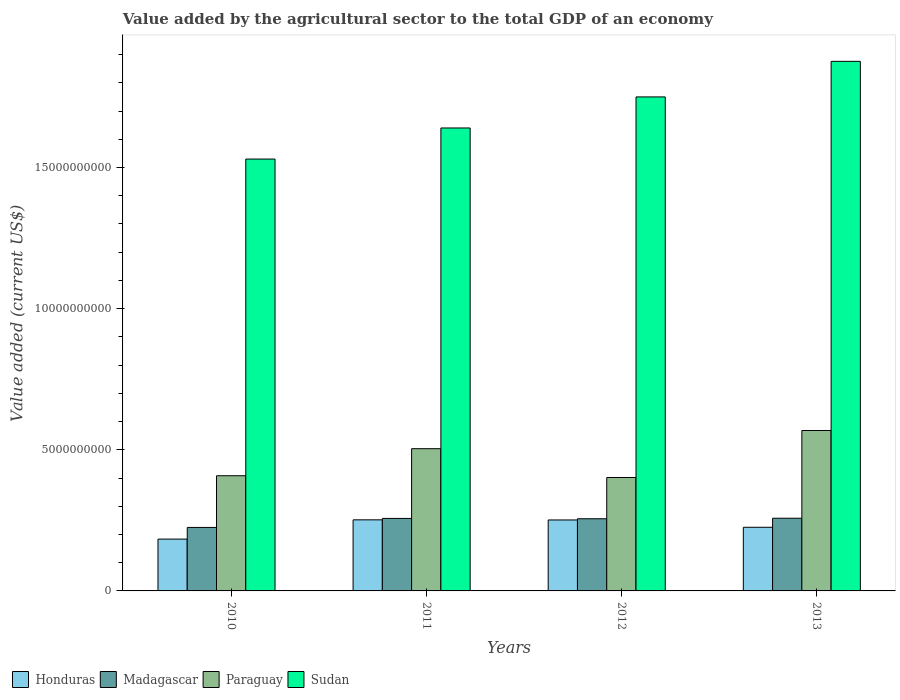How many different coloured bars are there?
Offer a very short reply. 4. How many bars are there on the 2nd tick from the left?
Your answer should be compact. 4. How many bars are there on the 4th tick from the right?
Give a very brief answer. 4. What is the label of the 2nd group of bars from the left?
Your response must be concise. 2011. What is the value added by the agricultural sector to the total GDP in Honduras in 2010?
Your answer should be compact. 1.84e+09. Across all years, what is the maximum value added by the agricultural sector to the total GDP in Honduras?
Give a very brief answer. 2.52e+09. Across all years, what is the minimum value added by the agricultural sector to the total GDP in Madagascar?
Provide a short and direct response. 2.25e+09. In which year was the value added by the agricultural sector to the total GDP in Madagascar maximum?
Keep it short and to the point. 2013. In which year was the value added by the agricultural sector to the total GDP in Madagascar minimum?
Your response must be concise. 2010. What is the total value added by the agricultural sector to the total GDP in Madagascar in the graph?
Offer a very short reply. 9.95e+09. What is the difference between the value added by the agricultural sector to the total GDP in Honduras in 2012 and that in 2013?
Keep it short and to the point. 2.59e+08. What is the difference between the value added by the agricultural sector to the total GDP in Sudan in 2011 and the value added by the agricultural sector to the total GDP in Honduras in 2012?
Give a very brief answer. 1.39e+1. What is the average value added by the agricultural sector to the total GDP in Sudan per year?
Your answer should be very brief. 1.70e+1. In the year 2011, what is the difference between the value added by the agricultural sector to the total GDP in Sudan and value added by the agricultural sector to the total GDP in Paraguay?
Provide a short and direct response. 1.14e+1. In how many years, is the value added by the agricultural sector to the total GDP in Honduras greater than 14000000000 US$?
Provide a succinct answer. 0. What is the ratio of the value added by the agricultural sector to the total GDP in Paraguay in 2010 to that in 2013?
Your answer should be compact. 0.72. Is the value added by the agricultural sector to the total GDP in Sudan in 2011 less than that in 2012?
Ensure brevity in your answer.  Yes. Is the difference between the value added by the agricultural sector to the total GDP in Sudan in 2012 and 2013 greater than the difference between the value added by the agricultural sector to the total GDP in Paraguay in 2012 and 2013?
Give a very brief answer. Yes. What is the difference between the highest and the second highest value added by the agricultural sector to the total GDP in Honduras?
Your response must be concise. 4.70e+06. What is the difference between the highest and the lowest value added by the agricultural sector to the total GDP in Honduras?
Offer a terse response. 6.82e+08. In how many years, is the value added by the agricultural sector to the total GDP in Honduras greater than the average value added by the agricultural sector to the total GDP in Honduras taken over all years?
Give a very brief answer. 2. What does the 3rd bar from the left in 2012 represents?
Make the answer very short. Paraguay. What does the 1st bar from the right in 2010 represents?
Ensure brevity in your answer.  Sudan. Is it the case that in every year, the sum of the value added by the agricultural sector to the total GDP in Paraguay and value added by the agricultural sector to the total GDP in Madagascar is greater than the value added by the agricultural sector to the total GDP in Honduras?
Keep it short and to the point. Yes. How many bars are there?
Provide a short and direct response. 16. Are all the bars in the graph horizontal?
Keep it short and to the point. No. Are the values on the major ticks of Y-axis written in scientific E-notation?
Your answer should be compact. No. Does the graph contain any zero values?
Provide a short and direct response. No. Does the graph contain grids?
Offer a very short reply. No. How are the legend labels stacked?
Provide a succinct answer. Horizontal. What is the title of the graph?
Provide a succinct answer. Value added by the agricultural sector to the total GDP of an economy. Does "Guinea" appear as one of the legend labels in the graph?
Your answer should be compact. No. What is the label or title of the X-axis?
Make the answer very short. Years. What is the label or title of the Y-axis?
Provide a short and direct response. Value added (current US$). What is the Value added (current US$) of Honduras in 2010?
Make the answer very short. 1.84e+09. What is the Value added (current US$) of Madagascar in 2010?
Offer a terse response. 2.25e+09. What is the Value added (current US$) of Paraguay in 2010?
Offer a very short reply. 4.08e+09. What is the Value added (current US$) of Sudan in 2010?
Give a very brief answer. 1.53e+1. What is the Value added (current US$) of Honduras in 2011?
Your answer should be compact. 2.52e+09. What is the Value added (current US$) of Madagascar in 2011?
Your answer should be compact. 2.57e+09. What is the Value added (current US$) of Paraguay in 2011?
Provide a short and direct response. 5.04e+09. What is the Value added (current US$) of Sudan in 2011?
Your answer should be compact. 1.64e+1. What is the Value added (current US$) in Honduras in 2012?
Your answer should be very brief. 2.51e+09. What is the Value added (current US$) in Madagascar in 2012?
Your answer should be compact. 2.56e+09. What is the Value added (current US$) in Paraguay in 2012?
Offer a terse response. 4.02e+09. What is the Value added (current US$) in Sudan in 2012?
Your response must be concise. 1.75e+1. What is the Value added (current US$) of Honduras in 2013?
Keep it short and to the point. 2.25e+09. What is the Value added (current US$) of Madagascar in 2013?
Your answer should be compact. 2.58e+09. What is the Value added (current US$) of Paraguay in 2013?
Offer a very short reply. 5.68e+09. What is the Value added (current US$) of Sudan in 2013?
Give a very brief answer. 1.88e+1. Across all years, what is the maximum Value added (current US$) of Honduras?
Offer a very short reply. 2.52e+09. Across all years, what is the maximum Value added (current US$) in Madagascar?
Provide a succinct answer. 2.58e+09. Across all years, what is the maximum Value added (current US$) in Paraguay?
Provide a short and direct response. 5.68e+09. Across all years, what is the maximum Value added (current US$) in Sudan?
Make the answer very short. 1.88e+1. Across all years, what is the minimum Value added (current US$) in Honduras?
Your answer should be very brief. 1.84e+09. Across all years, what is the minimum Value added (current US$) of Madagascar?
Give a very brief answer. 2.25e+09. Across all years, what is the minimum Value added (current US$) of Paraguay?
Give a very brief answer. 4.02e+09. Across all years, what is the minimum Value added (current US$) in Sudan?
Give a very brief answer. 1.53e+1. What is the total Value added (current US$) in Honduras in the graph?
Your answer should be compact. 9.12e+09. What is the total Value added (current US$) in Madagascar in the graph?
Provide a short and direct response. 9.95e+09. What is the total Value added (current US$) in Paraguay in the graph?
Make the answer very short. 1.88e+1. What is the total Value added (current US$) of Sudan in the graph?
Provide a short and direct response. 6.80e+1. What is the difference between the Value added (current US$) of Honduras in 2010 and that in 2011?
Give a very brief answer. -6.82e+08. What is the difference between the Value added (current US$) of Madagascar in 2010 and that in 2011?
Ensure brevity in your answer.  -3.19e+08. What is the difference between the Value added (current US$) of Paraguay in 2010 and that in 2011?
Provide a succinct answer. -9.58e+08. What is the difference between the Value added (current US$) in Sudan in 2010 and that in 2011?
Provide a short and direct response. -1.10e+09. What is the difference between the Value added (current US$) in Honduras in 2010 and that in 2012?
Ensure brevity in your answer.  -6.78e+08. What is the difference between the Value added (current US$) in Madagascar in 2010 and that in 2012?
Ensure brevity in your answer.  -3.07e+08. What is the difference between the Value added (current US$) in Paraguay in 2010 and that in 2012?
Provide a short and direct response. 6.20e+07. What is the difference between the Value added (current US$) in Sudan in 2010 and that in 2012?
Your answer should be compact. -2.20e+09. What is the difference between the Value added (current US$) of Honduras in 2010 and that in 2013?
Your response must be concise. -4.19e+08. What is the difference between the Value added (current US$) in Madagascar in 2010 and that in 2013?
Make the answer very short. -3.26e+08. What is the difference between the Value added (current US$) in Paraguay in 2010 and that in 2013?
Your answer should be very brief. -1.60e+09. What is the difference between the Value added (current US$) of Sudan in 2010 and that in 2013?
Give a very brief answer. -3.46e+09. What is the difference between the Value added (current US$) in Honduras in 2011 and that in 2012?
Your answer should be compact. 4.70e+06. What is the difference between the Value added (current US$) of Madagascar in 2011 and that in 2012?
Provide a succinct answer. 1.16e+07. What is the difference between the Value added (current US$) of Paraguay in 2011 and that in 2012?
Keep it short and to the point. 1.02e+09. What is the difference between the Value added (current US$) in Sudan in 2011 and that in 2012?
Give a very brief answer. -1.10e+09. What is the difference between the Value added (current US$) in Honduras in 2011 and that in 2013?
Your answer should be very brief. 2.63e+08. What is the difference between the Value added (current US$) in Madagascar in 2011 and that in 2013?
Provide a short and direct response. -7.38e+06. What is the difference between the Value added (current US$) of Paraguay in 2011 and that in 2013?
Provide a succinct answer. -6.44e+08. What is the difference between the Value added (current US$) of Sudan in 2011 and that in 2013?
Provide a short and direct response. -2.36e+09. What is the difference between the Value added (current US$) in Honduras in 2012 and that in 2013?
Offer a terse response. 2.59e+08. What is the difference between the Value added (current US$) of Madagascar in 2012 and that in 2013?
Your answer should be very brief. -1.90e+07. What is the difference between the Value added (current US$) of Paraguay in 2012 and that in 2013?
Ensure brevity in your answer.  -1.66e+09. What is the difference between the Value added (current US$) of Sudan in 2012 and that in 2013?
Your response must be concise. -1.26e+09. What is the difference between the Value added (current US$) in Honduras in 2010 and the Value added (current US$) in Madagascar in 2011?
Your answer should be compact. -7.32e+08. What is the difference between the Value added (current US$) in Honduras in 2010 and the Value added (current US$) in Paraguay in 2011?
Your response must be concise. -3.20e+09. What is the difference between the Value added (current US$) of Honduras in 2010 and the Value added (current US$) of Sudan in 2011?
Give a very brief answer. -1.46e+1. What is the difference between the Value added (current US$) of Madagascar in 2010 and the Value added (current US$) of Paraguay in 2011?
Offer a very short reply. -2.79e+09. What is the difference between the Value added (current US$) in Madagascar in 2010 and the Value added (current US$) in Sudan in 2011?
Offer a terse response. -1.42e+1. What is the difference between the Value added (current US$) in Paraguay in 2010 and the Value added (current US$) in Sudan in 2011?
Your response must be concise. -1.23e+1. What is the difference between the Value added (current US$) in Honduras in 2010 and the Value added (current US$) in Madagascar in 2012?
Your response must be concise. -7.21e+08. What is the difference between the Value added (current US$) of Honduras in 2010 and the Value added (current US$) of Paraguay in 2012?
Provide a short and direct response. -2.18e+09. What is the difference between the Value added (current US$) in Honduras in 2010 and the Value added (current US$) in Sudan in 2012?
Your answer should be very brief. -1.57e+1. What is the difference between the Value added (current US$) in Madagascar in 2010 and the Value added (current US$) in Paraguay in 2012?
Ensure brevity in your answer.  -1.77e+09. What is the difference between the Value added (current US$) of Madagascar in 2010 and the Value added (current US$) of Sudan in 2012?
Your answer should be compact. -1.53e+1. What is the difference between the Value added (current US$) of Paraguay in 2010 and the Value added (current US$) of Sudan in 2012?
Offer a terse response. -1.34e+1. What is the difference between the Value added (current US$) in Honduras in 2010 and the Value added (current US$) in Madagascar in 2013?
Your answer should be compact. -7.40e+08. What is the difference between the Value added (current US$) of Honduras in 2010 and the Value added (current US$) of Paraguay in 2013?
Offer a terse response. -3.85e+09. What is the difference between the Value added (current US$) in Honduras in 2010 and the Value added (current US$) in Sudan in 2013?
Offer a very short reply. -1.69e+1. What is the difference between the Value added (current US$) in Madagascar in 2010 and the Value added (current US$) in Paraguay in 2013?
Ensure brevity in your answer.  -3.43e+09. What is the difference between the Value added (current US$) in Madagascar in 2010 and the Value added (current US$) in Sudan in 2013?
Your response must be concise. -1.65e+1. What is the difference between the Value added (current US$) in Paraguay in 2010 and the Value added (current US$) in Sudan in 2013?
Ensure brevity in your answer.  -1.47e+1. What is the difference between the Value added (current US$) in Honduras in 2011 and the Value added (current US$) in Madagascar in 2012?
Provide a succinct answer. -3.82e+07. What is the difference between the Value added (current US$) of Honduras in 2011 and the Value added (current US$) of Paraguay in 2012?
Give a very brief answer. -1.50e+09. What is the difference between the Value added (current US$) of Honduras in 2011 and the Value added (current US$) of Sudan in 2012?
Provide a succinct answer. -1.50e+1. What is the difference between the Value added (current US$) of Madagascar in 2011 and the Value added (current US$) of Paraguay in 2012?
Give a very brief answer. -1.45e+09. What is the difference between the Value added (current US$) of Madagascar in 2011 and the Value added (current US$) of Sudan in 2012?
Your response must be concise. -1.49e+1. What is the difference between the Value added (current US$) in Paraguay in 2011 and the Value added (current US$) in Sudan in 2012?
Make the answer very short. -1.25e+1. What is the difference between the Value added (current US$) in Honduras in 2011 and the Value added (current US$) in Madagascar in 2013?
Offer a very short reply. -5.72e+07. What is the difference between the Value added (current US$) of Honduras in 2011 and the Value added (current US$) of Paraguay in 2013?
Provide a short and direct response. -3.16e+09. What is the difference between the Value added (current US$) of Honduras in 2011 and the Value added (current US$) of Sudan in 2013?
Your response must be concise. -1.62e+1. What is the difference between the Value added (current US$) in Madagascar in 2011 and the Value added (current US$) in Paraguay in 2013?
Provide a short and direct response. -3.12e+09. What is the difference between the Value added (current US$) of Madagascar in 2011 and the Value added (current US$) of Sudan in 2013?
Give a very brief answer. -1.62e+1. What is the difference between the Value added (current US$) of Paraguay in 2011 and the Value added (current US$) of Sudan in 2013?
Give a very brief answer. -1.37e+1. What is the difference between the Value added (current US$) in Honduras in 2012 and the Value added (current US$) in Madagascar in 2013?
Ensure brevity in your answer.  -6.19e+07. What is the difference between the Value added (current US$) of Honduras in 2012 and the Value added (current US$) of Paraguay in 2013?
Provide a short and direct response. -3.17e+09. What is the difference between the Value added (current US$) in Honduras in 2012 and the Value added (current US$) in Sudan in 2013?
Your response must be concise. -1.62e+1. What is the difference between the Value added (current US$) in Madagascar in 2012 and the Value added (current US$) in Paraguay in 2013?
Keep it short and to the point. -3.13e+09. What is the difference between the Value added (current US$) of Madagascar in 2012 and the Value added (current US$) of Sudan in 2013?
Your answer should be very brief. -1.62e+1. What is the difference between the Value added (current US$) of Paraguay in 2012 and the Value added (current US$) of Sudan in 2013?
Provide a succinct answer. -1.47e+1. What is the average Value added (current US$) in Honduras per year?
Give a very brief answer. 2.28e+09. What is the average Value added (current US$) of Madagascar per year?
Provide a succinct answer. 2.49e+09. What is the average Value added (current US$) of Paraguay per year?
Provide a short and direct response. 4.71e+09. What is the average Value added (current US$) in Sudan per year?
Offer a terse response. 1.70e+1. In the year 2010, what is the difference between the Value added (current US$) of Honduras and Value added (current US$) of Madagascar?
Make the answer very short. -4.13e+08. In the year 2010, what is the difference between the Value added (current US$) of Honduras and Value added (current US$) of Paraguay?
Keep it short and to the point. -2.24e+09. In the year 2010, what is the difference between the Value added (current US$) in Honduras and Value added (current US$) in Sudan?
Offer a terse response. -1.35e+1. In the year 2010, what is the difference between the Value added (current US$) in Madagascar and Value added (current US$) in Paraguay?
Keep it short and to the point. -1.83e+09. In the year 2010, what is the difference between the Value added (current US$) in Madagascar and Value added (current US$) in Sudan?
Ensure brevity in your answer.  -1.31e+1. In the year 2010, what is the difference between the Value added (current US$) in Paraguay and Value added (current US$) in Sudan?
Keep it short and to the point. -1.12e+1. In the year 2011, what is the difference between the Value added (current US$) in Honduras and Value added (current US$) in Madagascar?
Provide a succinct answer. -4.98e+07. In the year 2011, what is the difference between the Value added (current US$) of Honduras and Value added (current US$) of Paraguay?
Give a very brief answer. -2.52e+09. In the year 2011, what is the difference between the Value added (current US$) in Honduras and Value added (current US$) in Sudan?
Offer a very short reply. -1.39e+1. In the year 2011, what is the difference between the Value added (current US$) in Madagascar and Value added (current US$) in Paraguay?
Your answer should be very brief. -2.47e+09. In the year 2011, what is the difference between the Value added (current US$) in Madagascar and Value added (current US$) in Sudan?
Give a very brief answer. -1.38e+1. In the year 2011, what is the difference between the Value added (current US$) in Paraguay and Value added (current US$) in Sudan?
Make the answer very short. -1.14e+1. In the year 2012, what is the difference between the Value added (current US$) in Honduras and Value added (current US$) in Madagascar?
Your answer should be very brief. -4.29e+07. In the year 2012, what is the difference between the Value added (current US$) in Honduras and Value added (current US$) in Paraguay?
Provide a short and direct response. -1.50e+09. In the year 2012, what is the difference between the Value added (current US$) of Honduras and Value added (current US$) of Sudan?
Keep it short and to the point. -1.50e+1. In the year 2012, what is the difference between the Value added (current US$) in Madagascar and Value added (current US$) in Paraguay?
Ensure brevity in your answer.  -1.46e+09. In the year 2012, what is the difference between the Value added (current US$) of Madagascar and Value added (current US$) of Sudan?
Provide a succinct answer. -1.49e+1. In the year 2012, what is the difference between the Value added (current US$) in Paraguay and Value added (current US$) in Sudan?
Give a very brief answer. -1.35e+1. In the year 2013, what is the difference between the Value added (current US$) of Honduras and Value added (current US$) of Madagascar?
Offer a very short reply. -3.21e+08. In the year 2013, what is the difference between the Value added (current US$) of Honduras and Value added (current US$) of Paraguay?
Your response must be concise. -3.43e+09. In the year 2013, what is the difference between the Value added (current US$) of Honduras and Value added (current US$) of Sudan?
Ensure brevity in your answer.  -1.65e+1. In the year 2013, what is the difference between the Value added (current US$) in Madagascar and Value added (current US$) in Paraguay?
Give a very brief answer. -3.11e+09. In the year 2013, what is the difference between the Value added (current US$) of Madagascar and Value added (current US$) of Sudan?
Offer a very short reply. -1.62e+1. In the year 2013, what is the difference between the Value added (current US$) in Paraguay and Value added (current US$) in Sudan?
Your answer should be very brief. -1.31e+1. What is the ratio of the Value added (current US$) of Honduras in 2010 to that in 2011?
Provide a succinct answer. 0.73. What is the ratio of the Value added (current US$) of Madagascar in 2010 to that in 2011?
Your answer should be compact. 0.88. What is the ratio of the Value added (current US$) in Paraguay in 2010 to that in 2011?
Offer a very short reply. 0.81. What is the ratio of the Value added (current US$) in Sudan in 2010 to that in 2011?
Make the answer very short. 0.93. What is the ratio of the Value added (current US$) of Honduras in 2010 to that in 2012?
Your response must be concise. 0.73. What is the ratio of the Value added (current US$) in Madagascar in 2010 to that in 2012?
Provide a short and direct response. 0.88. What is the ratio of the Value added (current US$) in Paraguay in 2010 to that in 2012?
Your answer should be very brief. 1.02. What is the ratio of the Value added (current US$) of Sudan in 2010 to that in 2012?
Give a very brief answer. 0.87. What is the ratio of the Value added (current US$) in Honduras in 2010 to that in 2013?
Provide a succinct answer. 0.81. What is the ratio of the Value added (current US$) of Madagascar in 2010 to that in 2013?
Your answer should be compact. 0.87. What is the ratio of the Value added (current US$) in Paraguay in 2010 to that in 2013?
Offer a terse response. 0.72. What is the ratio of the Value added (current US$) of Sudan in 2010 to that in 2013?
Keep it short and to the point. 0.82. What is the ratio of the Value added (current US$) in Honduras in 2011 to that in 2012?
Make the answer very short. 1. What is the ratio of the Value added (current US$) of Madagascar in 2011 to that in 2012?
Your response must be concise. 1. What is the ratio of the Value added (current US$) of Paraguay in 2011 to that in 2012?
Give a very brief answer. 1.25. What is the ratio of the Value added (current US$) of Sudan in 2011 to that in 2012?
Your answer should be very brief. 0.94. What is the ratio of the Value added (current US$) in Honduras in 2011 to that in 2013?
Offer a terse response. 1.12. What is the ratio of the Value added (current US$) of Madagascar in 2011 to that in 2013?
Offer a very short reply. 1. What is the ratio of the Value added (current US$) in Paraguay in 2011 to that in 2013?
Offer a very short reply. 0.89. What is the ratio of the Value added (current US$) in Sudan in 2011 to that in 2013?
Provide a succinct answer. 0.87. What is the ratio of the Value added (current US$) in Honduras in 2012 to that in 2013?
Offer a very short reply. 1.11. What is the ratio of the Value added (current US$) in Paraguay in 2012 to that in 2013?
Offer a very short reply. 0.71. What is the ratio of the Value added (current US$) of Sudan in 2012 to that in 2013?
Offer a terse response. 0.93. What is the difference between the highest and the second highest Value added (current US$) in Honduras?
Offer a terse response. 4.70e+06. What is the difference between the highest and the second highest Value added (current US$) of Madagascar?
Your answer should be compact. 7.38e+06. What is the difference between the highest and the second highest Value added (current US$) in Paraguay?
Your response must be concise. 6.44e+08. What is the difference between the highest and the second highest Value added (current US$) in Sudan?
Your answer should be compact. 1.26e+09. What is the difference between the highest and the lowest Value added (current US$) in Honduras?
Give a very brief answer. 6.82e+08. What is the difference between the highest and the lowest Value added (current US$) in Madagascar?
Your answer should be compact. 3.26e+08. What is the difference between the highest and the lowest Value added (current US$) of Paraguay?
Make the answer very short. 1.66e+09. What is the difference between the highest and the lowest Value added (current US$) of Sudan?
Your answer should be very brief. 3.46e+09. 